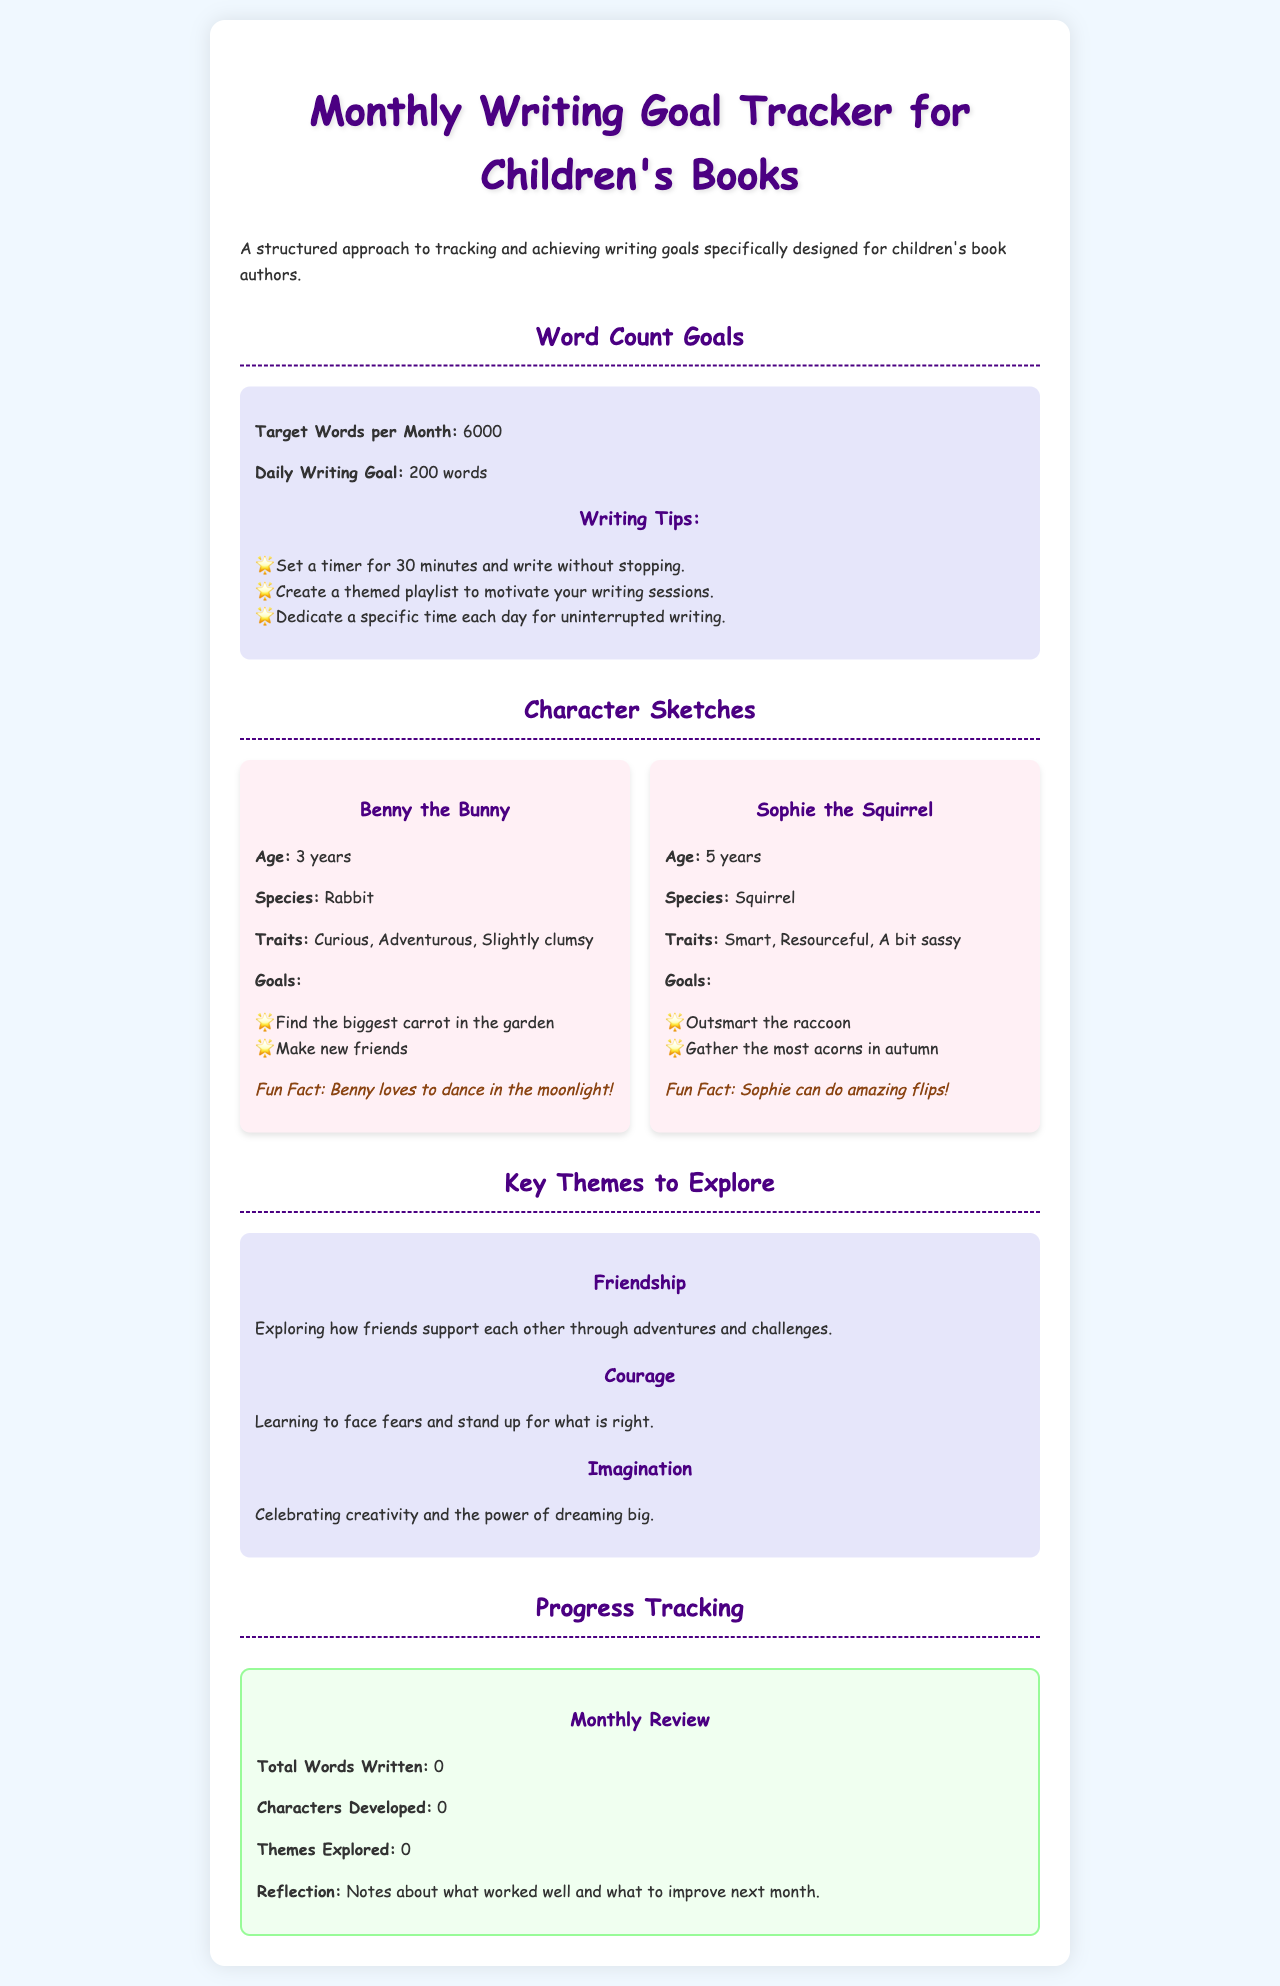What is the target words per month? The document specifies the target words per month to be a certain number in the goals section.
Answer: 6000 What is Benny the Bunny's fun fact? The fun fact about Benny is specifically mentioned in the character sketches section of the document.
Answer: Benny loves to dance in the moonlight! What are the daily writing goals? The daily writing goal is outlined in the writing goals section as a specific number.
Answer: 200 words Which character is described as smart and sassy? The character with these traits is listed in the character sketches.
Answer: Sophie the Squirrel What is one of the key themes to explore? The document lists various themes that authors can explore in their writing.
Answer: Friendship How many characters can be developed according to the tracker? The document states the maximum number of characters that can be developed in tracking progress.
Answer: 5 What is the primary purpose of this manual? The primary purpose is mentioned in the introductory paragraph, outlining the focus of the content.
Answer: To track and achieve writing goals What should be included in the reflection section? The document specifies what authors should consider in their reflection on monthly progress.
Answer: Notes about what worked well and what to improve next month 